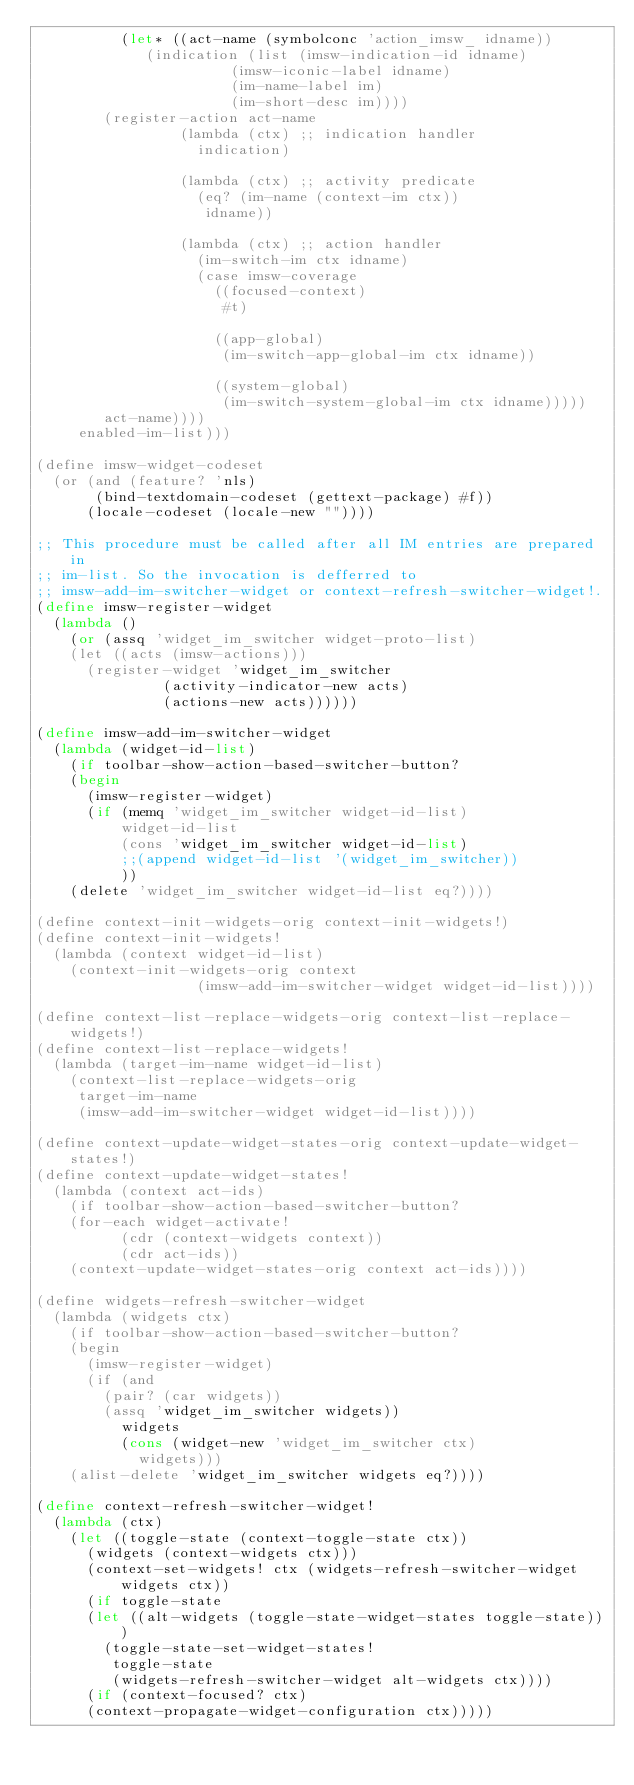<code> <loc_0><loc_0><loc_500><loc_500><_Scheme_>	      (let* ((act-name (symbolconc 'action_imsw_ idname))
		     (indication (list (imsw-indication-id idname)
				       (imsw-iconic-label idname)
				       (im-name-label im)
				       (im-short-desc im))))
		(register-action act-name
				 (lambda (ctx) ;; indication handler
				   indication)

				 (lambda (ctx) ;; activity predicate
				   (eq? (im-name (context-im ctx))
					idname))

				 (lambda (ctx) ;; action handler
				   (im-switch-im ctx idname)
				   (case imsw-coverage
				     ((focused-context)
				      #t)

				     ((app-global)
				      (im-switch-app-global-im ctx idname))

				     ((system-global)
				      (im-switch-system-global-im ctx idname)))))
		act-name))))
     enabled-im-list)))

(define imsw-widget-codeset
  (or (and (feature? 'nls)
	   (bind-textdomain-codeset (gettext-package) #f))
      (locale-codeset (locale-new ""))))

;; This procedure must be called after all IM entries are prepared in
;; im-list. So the invocation is defferred to
;; imsw-add-im-switcher-widget or context-refresh-switcher-widget!.
(define imsw-register-widget
  (lambda ()
    (or (assq 'widget_im_switcher widget-proto-list)
	(let ((acts (imsw-actions)))
	  (register-widget 'widget_im_switcher
			   (activity-indicator-new acts)
			   (actions-new acts))))))

(define imsw-add-im-switcher-widget
  (lambda (widget-id-list)
    (if toolbar-show-action-based-switcher-button?
	(begin
	  (imsw-register-widget)
	  (if (memq 'widget_im_switcher widget-id-list)
	      widget-id-list
	      (cons 'widget_im_switcher widget-id-list)
	      ;;(append widget-id-list '(widget_im_switcher))
	      ))
	(delete 'widget_im_switcher widget-id-list eq?))))

(define context-init-widgets-orig context-init-widgets!)
(define context-init-widgets!
  (lambda (context widget-id-list)
    (context-init-widgets-orig context
			       (imsw-add-im-switcher-widget widget-id-list))))

(define context-list-replace-widgets-orig context-list-replace-widgets!)
(define context-list-replace-widgets!
  (lambda (target-im-name widget-id-list)
    (context-list-replace-widgets-orig
     target-im-name
     (imsw-add-im-switcher-widget widget-id-list))))

(define context-update-widget-states-orig context-update-widget-states!)
(define context-update-widget-states!
  (lambda (context act-ids)
    (if toolbar-show-action-based-switcher-button?
	(for-each widget-activate!
		  (cdr (context-widgets context))
		  (cdr act-ids))
	(context-update-widget-states-orig context act-ids))))

(define widgets-refresh-switcher-widget
  (lambda (widgets ctx)
    (if toolbar-show-action-based-switcher-button?
	(begin
	  (imsw-register-widget)
	  (if (and
		(pair? (car widgets))
		(assq 'widget_im_switcher widgets))
	      widgets
	      (cons (widget-new 'widget_im_switcher ctx)
		    widgets)))
	(alist-delete 'widget_im_switcher widgets eq?))))

(define context-refresh-switcher-widget!
  (lambda (ctx)
    (let ((toggle-state (context-toggle-state ctx))
	  (widgets (context-widgets ctx)))
      (context-set-widgets! ctx (widgets-refresh-switcher-widget widgets ctx))
      (if toggle-state
	  (let ((alt-widgets (toggle-state-widget-states toggle-state)))
	    (toggle-state-set-widget-states!
	     toggle-state
	     (widgets-refresh-switcher-widget alt-widgets ctx))))
      (if (context-focused? ctx)
	  (context-propagate-widget-configuration ctx)))))
</code> 